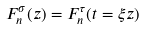Convert formula to latex. <formula><loc_0><loc_0><loc_500><loc_500>F _ { n } ^ { \sigma } ( z ) = F _ { n } ^ { \tau } ( t = \xi z )</formula> 